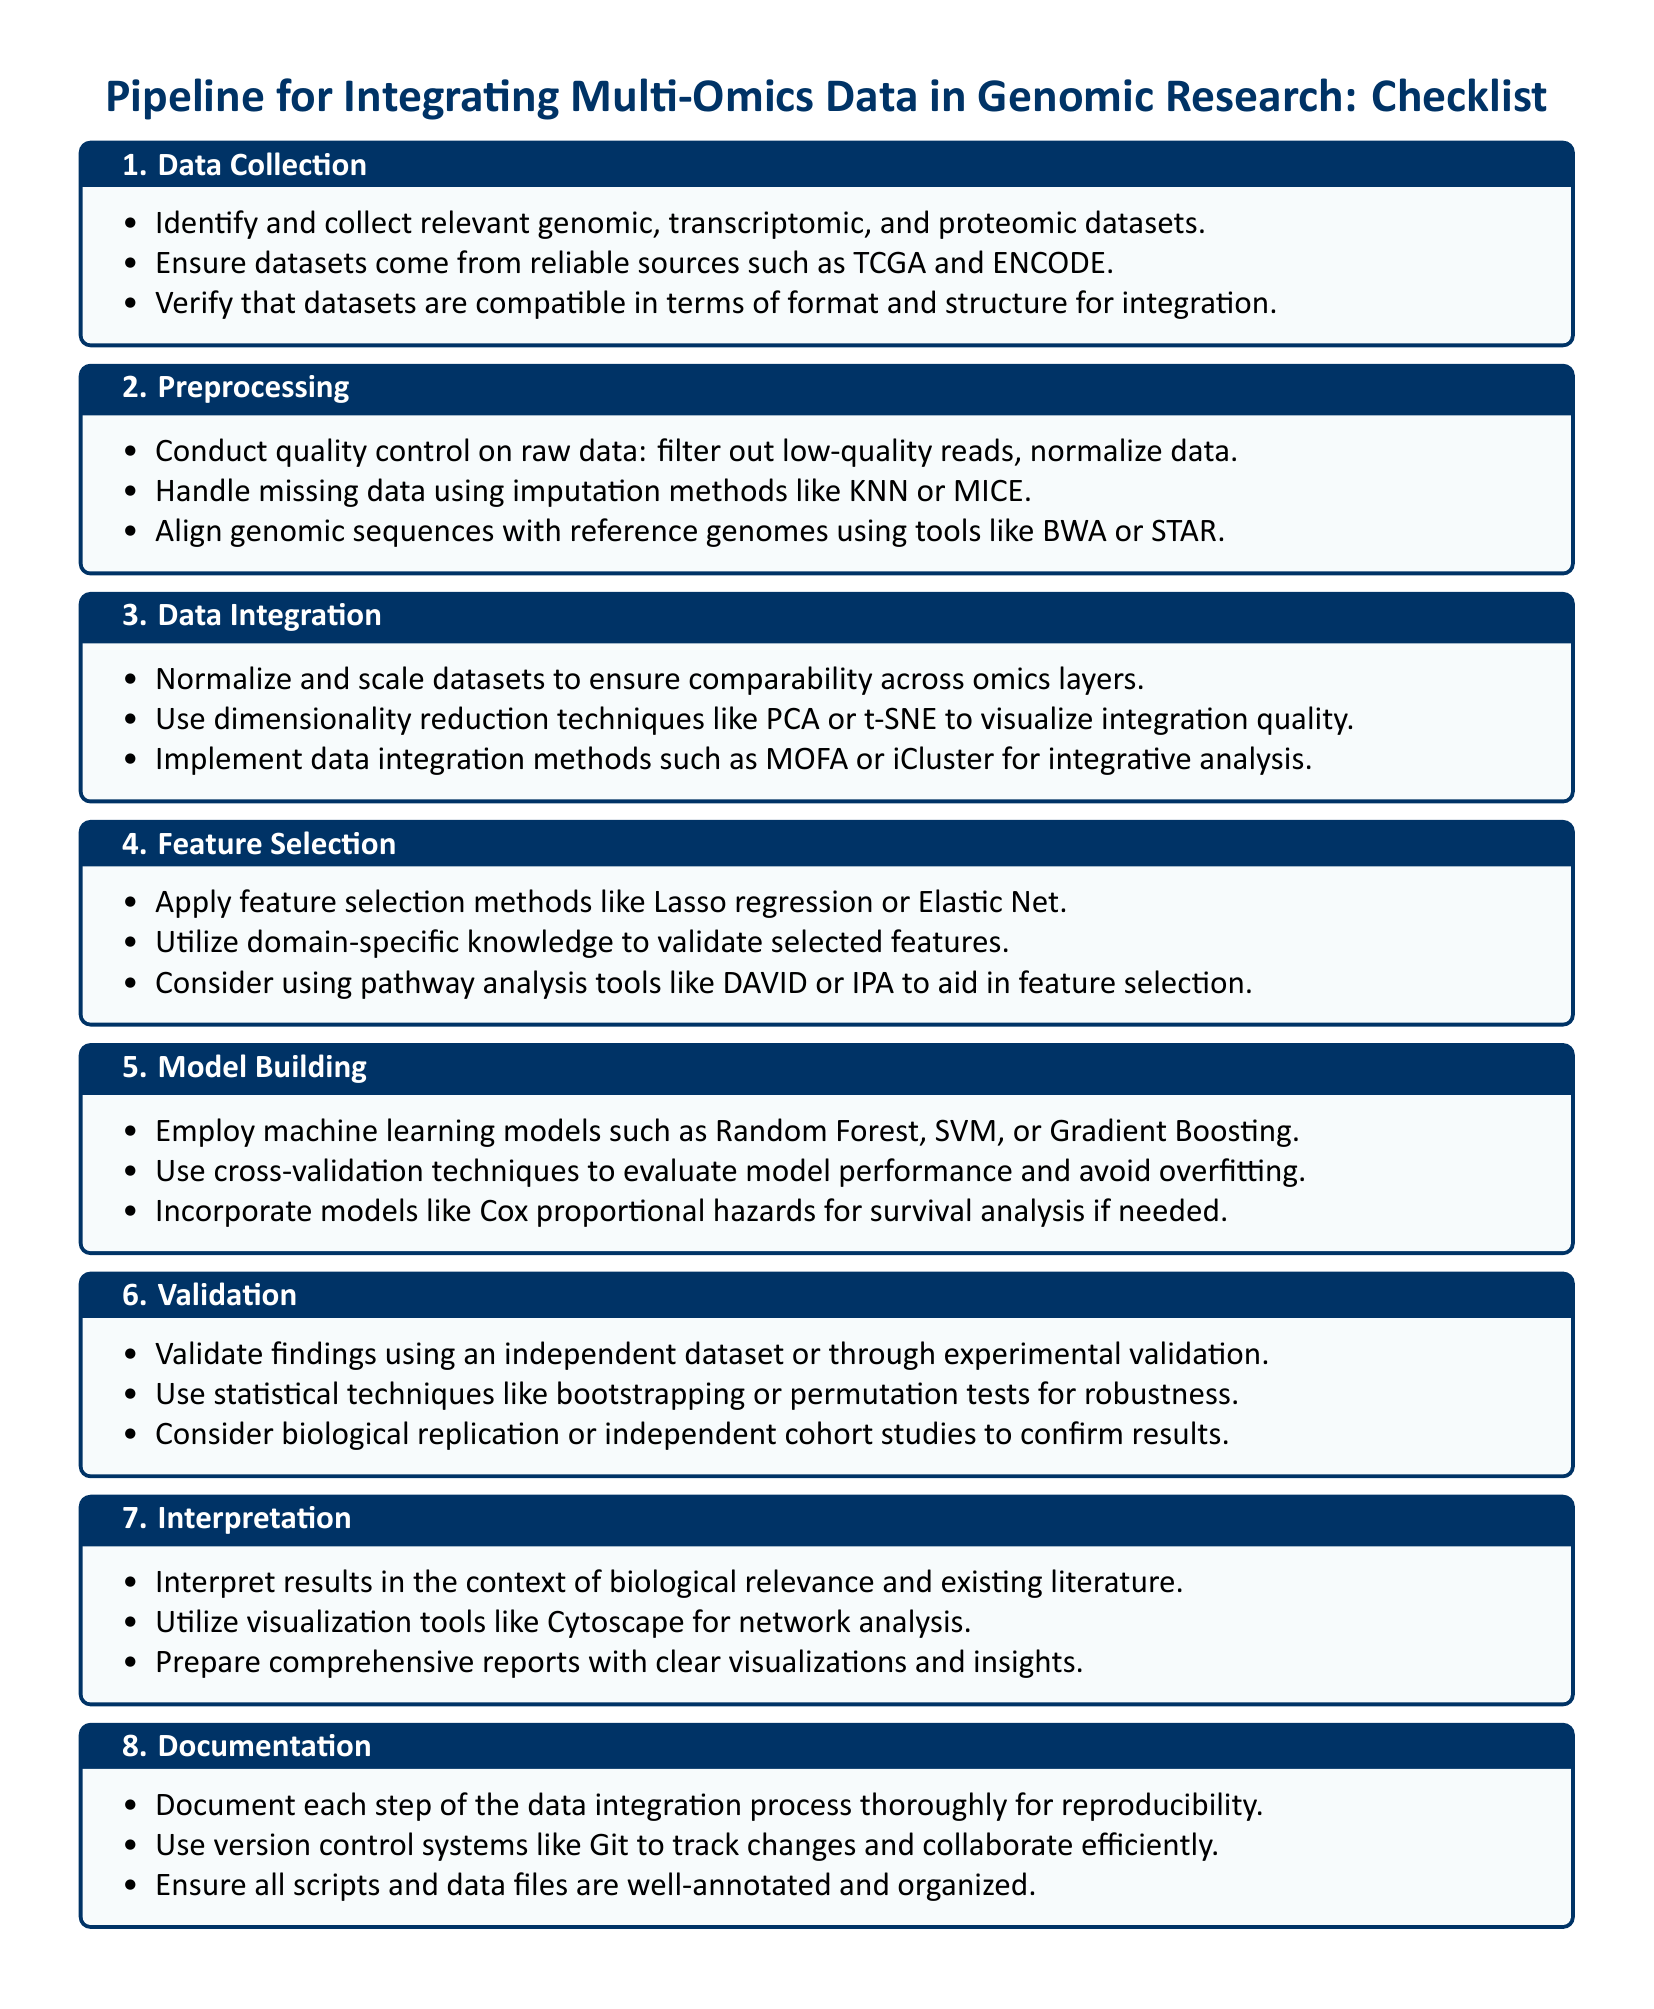what is the first step in the pipeline? The first step outlined in the checklist for integrating multi-omics data is data collection.
Answer: data collection which normalization technique is mentioned for dataset comparisons? The checklist specifies normalizing and scaling datasets to ensure comparability across omics layers.
Answer: normalizing and scaling what method is suggested for handling missing data? The checklist mentions using imputation methods like KNN or MICE for handling missing data.
Answer: KNN or MICE which model is recommended for survival analysis? The document suggests incorporating models like Cox proportional hazards for survival analysis if needed.
Answer: Cox proportional hazards what tool can be used for network analysis? The checklist recommends utilizing visualization tools like Cytoscape for network analysis.
Answer: Cytoscape how many main steps are listed in the checklist? The checklist lists a total of eight main steps for integrating multi-omics data in genomic research.
Answer: eight what type of validation is advised in the checklist? The checklist emphasizes validating findings using either independent datasets or through experimental validation.
Answer: independent dataset or experimental validation which version control system is suggested for documentation? The checklist mentions using version control systems like Git for tracking changes and collaboration.
Answer: Git 